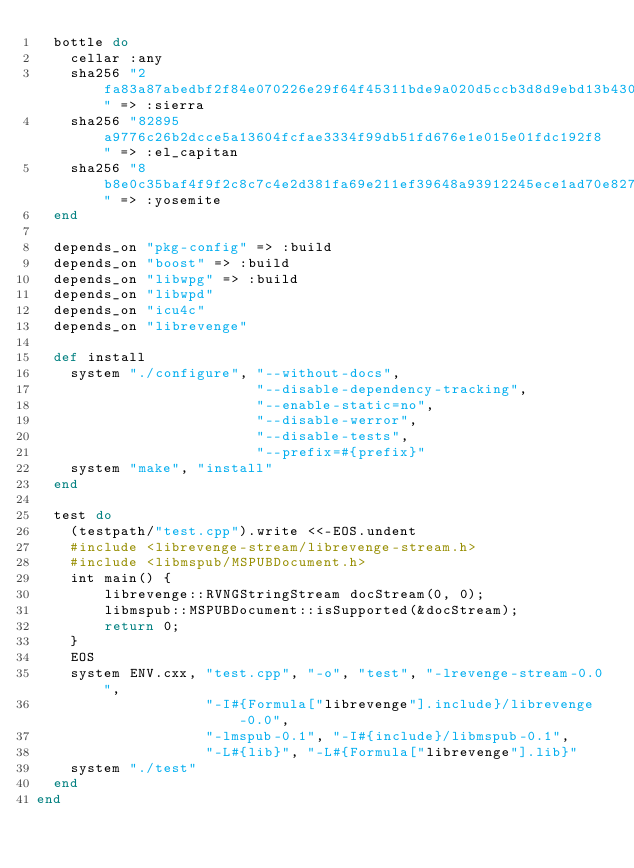Convert code to text. <code><loc_0><loc_0><loc_500><loc_500><_Ruby_>  bottle do
    cellar :any
    sha256 "2fa83a87abedbf2f84e070226e29f64f45311bde9a020d5ccb3d8d9ebd13b430" => :sierra
    sha256 "82895a9776c26b2dcce5a13604fcfae3334f99db51fd676e1e015e01fdc192f8" => :el_capitan
    sha256 "8b8e0c35baf4f9f2c8c7c4e2d381fa69e211ef39648a93912245ece1ad70e827" => :yosemite
  end

  depends_on "pkg-config" => :build
  depends_on "boost" => :build
  depends_on "libwpg" => :build
  depends_on "libwpd"
  depends_on "icu4c"
  depends_on "librevenge"

  def install
    system "./configure", "--without-docs",
                          "--disable-dependency-tracking",
                          "--enable-static=no",
                          "--disable-werror",
                          "--disable-tests",
                          "--prefix=#{prefix}"
    system "make", "install"
  end

  test do
    (testpath/"test.cpp").write <<-EOS.undent
    #include <librevenge-stream/librevenge-stream.h>
    #include <libmspub/MSPUBDocument.h>
    int main() {
        librevenge::RVNGStringStream docStream(0, 0);
        libmspub::MSPUBDocument::isSupported(&docStream);
        return 0;
    }
    EOS
    system ENV.cxx, "test.cpp", "-o", "test", "-lrevenge-stream-0.0",
                    "-I#{Formula["librevenge"].include}/librevenge-0.0",
                    "-lmspub-0.1", "-I#{include}/libmspub-0.1",
                    "-L#{lib}", "-L#{Formula["librevenge"].lib}"
    system "./test"
  end
end
</code> 